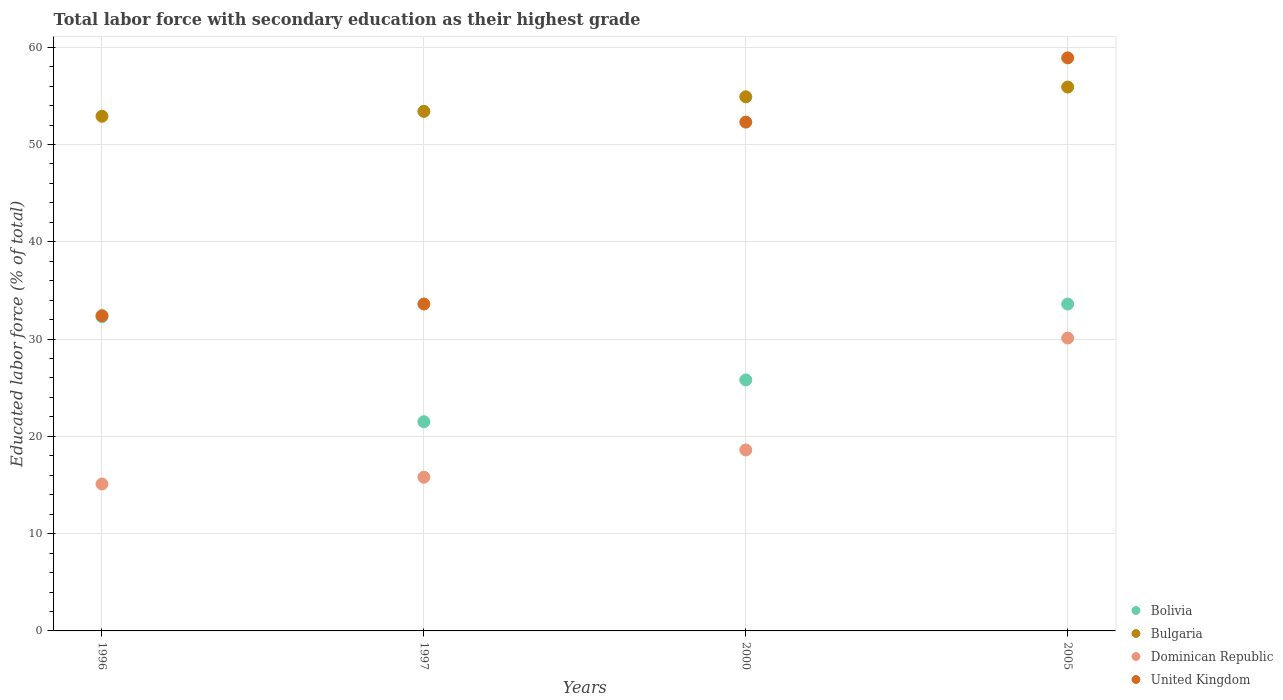How many different coloured dotlines are there?
Make the answer very short. 4. Is the number of dotlines equal to the number of legend labels?
Give a very brief answer. Yes. What is the percentage of total labor force with primary education in Bolivia in 1996?
Your answer should be compact. 32.3. Across all years, what is the maximum percentage of total labor force with primary education in United Kingdom?
Offer a very short reply. 58.9. Across all years, what is the minimum percentage of total labor force with primary education in Bulgaria?
Offer a very short reply. 52.9. In which year was the percentage of total labor force with primary education in Dominican Republic minimum?
Keep it short and to the point. 1996. What is the total percentage of total labor force with primary education in Bulgaria in the graph?
Your response must be concise. 217.1. What is the difference between the percentage of total labor force with primary education in Dominican Republic in 1997 and that in 2005?
Give a very brief answer. -14.3. What is the average percentage of total labor force with primary education in Bolivia per year?
Your response must be concise. 28.3. In the year 2000, what is the difference between the percentage of total labor force with primary education in Bolivia and percentage of total labor force with primary education in United Kingdom?
Make the answer very short. -26.5. What is the ratio of the percentage of total labor force with primary education in Bulgaria in 2000 to that in 2005?
Give a very brief answer. 0.98. Is the percentage of total labor force with primary education in United Kingdom in 1996 less than that in 2005?
Offer a terse response. Yes. What is the difference between the highest and the second highest percentage of total labor force with primary education in Dominican Republic?
Offer a terse response. 11.5. What is the difference between the highest and the lowest percentage of total labor force with primary education in United Kingdom?
Offer a very short reply. 26.5. In how many years, is the percentage of total labor force with primary education in Dominican Republic greater than the average percentage of total labor force with primary education in Dominican Republic taken over all years?
Your response must be concise. 1. Is the sum of the percentage of total labor force with primary education in Bolivia in 1996 and 2005 greater than the maximum percentage of total labor force with primary education in Dominican Republic across all years?
Make the answer very short. Yes. Is it the case that in every year, the sum of the percentage of total labor force with primary education in Bulgaria and percentage of total labor force with primary education in Dominican Republic  is greater than the sum of percentage of total labor force with primary education in United Kingdom and percentage of total labor force with primary education in Bolivia?
Give a very brief answer. No. Is it the case that in every year, the sum of the percentage of total labor force with primary education in Bolivia and percentage of total labor force with primary education in Dominican Republic  is greater than the percentage of total labor force with primary education in United Kingdom?
Provide a succinct answer. No. How many dotlines are there?
Offer a very short reply. 4. What is the difference between two consecutive major ticks on the Y-axis?
Provide a short and direct response. 10. Are the values on the major ticks of Y-axis written in scientific E-notation?
Ensure brevity in your answer.  No. Does the graph contain any zero values?
Give a very brief answer. No. Where does the legend appear in the graph?
Give a very brief answer. Bottom right. How many legend labels are there?
Provide a succinct answer. 4. What is the title of the graph?
Ensure brevity in your answer.  Total labor force with secondary education as their highest grade. Does "Germany" appear as one of the legend labels in the graph?
Keep it short and to the point. No. What is the label or title of the X-axis?
Provide a succinct answer. Years. What is the label or title of the Y-axis?
Offer a terse response. Educated labor force (% of total). What is the Educated labor force (% of total) of Bolivia in 1996?
Your answer should be very brief. 32.3. What is the Educated labor force (% of total) in Bulgaria in 1996?
Ensure brevity in your answer.  52.9. What is the Educated labor force (% of total) of Dominican Republic in 1996?
Keep it short and to the point. 15.1. What is the Educated labor force (% of total) in United Kingdom in 1996?
Your answer should be compact. 32.4. What is the Educated labor force (% of total) of Bolivia in 1997?
Ensure brevity in your answer.  21.5. What is the Educated labor force (% of total) of Bulgaria in 1997?
Provide a succinct answer. 53.4. What is the Educated labor force (% of total) in Dominican Republic in 1997?
Provide a short and direct response. 15.8. What is the Educated labor force (% of total) in United Kingdom in 1997?
Make the answer very short. 33.6. What is the Educated labor force (% of total) of Bolivia in 2000?
Your answer should be very brief. 25.8. What is the Educated labor force (% of total) in Bulgaria in 2000?
Your answer should be very brief. 54.9. What is the Educated labor force (% of total) of Dominican Republic in 2000?
Provide a short and direct response. 18.6. What is the Educated labor force (% of total) in United Kingdom in 2000?
Offer a very short reply. 52.3. What is the Educated labor force (% of total) of Bolivia in 2005?
Offer a terse response. 33.6. What is the Educated labor force (% of total) of Bulgaria in 2005?
Your answer should be very brief. 55.9. What is the Educated labor force (% of total) in Dominican Republic in 2005?
Keep it short and to the point. 30.1. What is the Educated labor force (% of total) in United Kingdom in 2005?
Ensure brevity in your answer.  58.9. Across all years, what is the maximum Educated labor force (% of total) in Bolivia?
Offer a terse response. 33.6. Across all years, what is the maximum Educated labor force (% of total) in Bulgaria?
Your answer should be very brief. 55.9. Across all years, what is the maximum Educated labor force (% of total) of Dominican Republic?
Offer a very short reply. 30.1. Across all years, what is the maximum Educated labor force (% of total) of United Kingdom?
Keep it short and to the point. 58.9. Across all years, what is the minimum Educated labor force (% of total) in Bolivia?
Give a very brief answer. 21.5. Across all years, what is the minimum Educated labor force (% of total) of Bulgaria?
Your answer should be compact. 52.9. Across all years, what is the minimum Educated labor force (% of total) in Dominican Republic?
Ensure brevity in your answer.  15.1. Across all years, what is the minimum Educated labor force (% of total) in United Kingdom?
Your answer should be compact. 32.4. What is the total Educated labor force (% of total) of Bolivia in the graph?
Make the answer very short. 113.2. What is the total Educated labor force (% of total) of Bulgaria in the graph?
Offer a very short reply. 217.1. What is the total Educated labor force (% of total) of Dominican Republic in the graph?
Ensure brevity in your answer.  79.6. What is the total Educated labor force (% of total) in United Kingdom in the graph?
Your answer should be compact. 177.2. What is the difference between the Educated labor force (% of total) in Bolivia in 1996 and that in 1997?
Offer a terse response. 10.8. What is the difference between the Educated labor force (% of total) of Bulgaria in 1996 and that in 1997?
Your answer should be very brief. -0.5. What is the difference between the Educated labor force (% of total) in Dominican Republic in 1996 and that in 1997?
Ensure brevity in your answer.  -0.7. What is the difference between the Educated labor force (% of total) in Bolivia in 1996 and that in 2000?
Your answer should be compact. 6.5. What is the difference between the Educated labor force (% of total) in Bulgaria in 1996 and that in 2000?
Your response must be concise. -2. What is the difference between the Educated labor force (% of total) in United Kingdom in 1996 and that in 2000?
Your answer should be compact. -19.9. What is the difference between the Educated labor force (% of total) of Bulgaria in 1996 and that in 2005?
Give a very brief answer. -3. What is the difference between the Educated labor force (% of total) in United Kingdom in 1996 and that in 2005?
Give a very brief answer. -26.5. What is the difference between the Educated labor force (% of total) of Bolivia in 1997 and that in 2000?
Keep it short and to the point. -4.3. What is the difference between the Educated labor force (% of total) in Bulgaria in 1997 and that in 2000?
Keep it short and to the point. -1.5. What is the difference between the Educated labor force (% of total) of Dominican Republic in 1997 and that in 2000?
Ensure brevity in your answer.  -2.8. What is the difference between the Educated labor force (% of total) of United Kingdom in 1997 and that in 2000?
Make the answer very short. -18.7. What is the difference between the Educated labor force (% of total) of Dominican Republic in 1997 and that in 2005?
Ensure brevity in your answer.  -14.3. What is the difference between the Educated labor force (% of total) in United Kingdom in 1997 and that in 2005?
Your answer should be very brief. -25.3. What is the difference between the Educated labor force (% of total) of Dominican Republic in 2000 and that in 2005?
Keep it short and to the point. -11.5. What is the difference between the Educated labor force (% of total) in United Kingdom in 2000 and that in 2005?
Make the answer very short. -6.6. What is the difference between the Educated labor force (% of total) in Bolivia in 1996 and the Educated labor force (% of total) in Bulgaria in 1997?
Ensure brevity in your answer.  -21.1. What is the difference between the Educated labor force (% of total) in Bolivia in 1996 and the Educated labor force (% of total) in Dominican Republic in 1997?
Offer a terse response. 16.5. What is the difference between the Educated labor force (% of total) of Bolivia in 1996 and the Educated labor force (% of total) of United Kingdom in 1997?
Give a very brief answer. -1.3. What is the difference between the Educated labor force (% of total) in Bulgaria in 1996 and the Educated labor force (% of total) in Dominican Republic in 1997?
Your answer should be compact. 37.1. What is the difference between the Educated labor force (% of total) in Bulgaria in 1996 and the Educated labor force (% of total) in United Kingdom in 1997?
Offer a terse response. 19.3. What is the difference between the Educated labor force (% of total) of Dominican Republic in 1996 and the Educated labor force (% of total) of United Kingdom in 1997?
Offer a very short reply. -18.5. What is the difference between the Educated labor force (% of total) in Bolivia in 1996 and the Educated labor force (% of total) in Bulgaria in 2000?
Provide a short and direct response. -22.6. What is the difference between the Educated labor force (% of total) of Bolivia in 1996 and the Educated labor force (% of total) of United Kingdom in 2000?
Your answer should be compact. -20. What is the difference between the Educated labor force (% of total) of Bulgaria in 1996 and the Educated labor force (% of total) of Dominican Republic in 2000?
Provide a succinct answer. 34.3. What is the difference between the Educated labor force (% of total) in Bulgaria in 1996 and the Educated labor force (% of total) in United Kingdom in 2000?
Ensure brevity in your answer.  0.6. What is the difference between the Educated labor force (% of total) of Dominican Republic in 1996 and the Educated labor force (% of total) of United Kingdom in 2000?
Give a very brief answer. -37.2. What is the difference between the Educated labor force (% of total) of Bolivia in 1996 and the Educated labor force (% of total) of Bulgaria in 2005?
Give a very brief answer. -23.6. What is the difference between the Educated labor force (% of total) of Bolivia in 1996 and the Educated labor force (% of total) of United Kingdom in 2005?
Your response must be concise. -26.6. What is the difference between the Educated labor force (% of total) of Bulgaria in 1996 and the Educated labor force (% of total) of Dominican Republic in 2005?
Provide a succinct answer. 22.8. What is the difference between the Educated labor force (% of total) in Bulgaria in 1996 and the Educated labor force (% of total) in United Kingdom in 2005?
Your answer should be very brief. -6. What is the difference between the Educated labor force (% of total) in Dominican Republic in 1996 and the Educated labor force (% of total) in United Kingdom in 2005?
Provide a short and direct response. -43.8. What is the difference between the Educated labor force (% of total) in Bolivia in 1997 and the Educated labor force (% of total) in Bulgaria in 2000?
Your response must be concise. -33.4. What is the difference between the Educated labor force (% of total) of Bolivia in 1997 and the Educated labor force (% of total) of Dominican Republic in 2000?
Offer a very short reply. 2.9. What is the difference between the Educated labor force (% of total) in Bolivia in 1997 and the Educated labor force (% of total) in United Kingdom in 2000?
Offer a terse response. -30.8. What is the difference between the Educated labor force (% of total) in Bulgaria in 1997 and the Educated labor force (% of total) in Dominican Republic in 2000?
Your response must be concise. 34.8. What is the difference between the Educated labor force (% of total) in Bulgaria in 1997 and the Educated labor force (% of total) in United Kingdom in 2000?
Offer a terse response. 1.1. What is the difference between the Educated labor force (% of total) in Dominican Republic in 1997 and the Educated labor force (% of total) in United Kingdom in 2000?
Make the answer very short. -36.5. What is the difference between the Educated labor force (% of total) of Bolivia in 1997 and the Educated labor force (% of total) of Bulgaria in 2005?
Ensure brevity in your answer.  -34.4. What is the difference between the Educated labor force (% of total) in Bolivia in 1997 and the Educated labor force (% of total) in United Kingdom in 2005?
Provide a short and direct response. -37.4. What is the difference between the Educated labor force (% of total) of Bulgaria in 1997 and the Educated labor force (% of total) of Dominican Republic in 2005?
Your answer should be compact. 23.3. What is the difference between the Educated labor force (% of total) of Bulgaria in 1997 and the Educated labor force (% of total) of United Kingdom in 2005?
Keep it short and to the point. -5.5. What is the difference between the Educated labor force (% of total) of Dominican Republic in 1997 and the Educated labor force (% of total) of United Kingdom in 2005?
Offer a terse response. -43.1. What is the difference between the Educated labor force (% of total) of Bolivia in 2000 and the Educated labor force (% of total) of Bulgaria in 2005?
Your response must be concise. -30.1. What is the difference between the Educated labor force (% of total) in Bolivia in 2000 and the Educated labor force (% of total) in Dominican Republic in 2005?
Keep it short and to the point. -4.3. What is the difference between the Educated labor force (% of total) in Bolivia in 2000 and the Educated labor force (% of total) in United Kingdom in 2005?
Offer a terse response. -33.1. What is the difference between the Educated labor force (% of total) of Bulgaria in 2000 and the Educated labor force (% of total) of Dominican Republic in 2005?
Provide a short and direct response. 24.8. What is the difference between the Educated labor force (% of total) in Dominican Republic in 2000 and the Educated labor force (% of total) in United Kingdom in 2005?
Your response must be concise. -40.3. What is the average Educated labor force (% of total) in Bolivia per year?
Keep it short and to the point. 28.3. What is the average Educated labor force (% of total) of Bulgaria per year?
Make the answer very short. 54.27. What is the average Educated labor force (% of total) in United Kingdom per year?
Offer a terse response. 44.3. In the year 1996, what is the difference between the Educated labor force (% of total) of Bolivia and Educated labor force (% of total) of Bulgaria?
Your response must be concise. -20.6. In the year 1996, what is the difference between the Educated labor force (% of total) of Bolivia and Educated labor force (% of total) of United Kingdom?
Your answer should be very brief. -0.1. In the year 1996, what is the difference between the Educated labor force (% of total) in Bulgaria and Educated labor force (% of total) in Dominican Republic?
Ensure brevity in your answer.  37.8. In the year 1996, what is the difference between the Educated labor force (% of total) in Dominican Republic and Educated labor force (% of total) in United Kingdom?
Offer a terse response. -17.3. In the year 1997, what is the difference between the Educated labor force (% of total) of Bolivia and Educated labor force (% of total) of Bulgaria?
Your answer should be compact. -31.9. In the year 1997, what is the difference between the Educated labor force (% of total) in Bolivia and Educated labor force (% of total) in Dominican Republic?
Provide a short and direct response. 5.7. In the year 1997, what is the difference between the Educated labor force (% of total) of Bolivia and Educated labor force (% of total) of United Kingdom?
Offer a terse response. -12.1. In the year 1997, what is the difference between the Educated labor force (% of total) in Bulgaria and Educated labor force (% of total) in Dominican Republic?
Ensure brevity in your answer.  37.6. In the year 1997, what is the difference between the Educated labor force (% of total) in Bulgaria and Educated labor force (% of total) in United Kingdom?
Keep it short and to the point. 19.8. In the year 1997, what is the difference between the Educated labor force (% of total) of Dominican Republic and Educated labor force (% of total) of United Kingdom?
Provide a short and direct response. -17.8. In the year 2000, what is the difference between the Educated labor force (% of total) of Bolivia and Educated labor force (% of total) of Bulgaria?
Your response must be concise. -29.1. In the year 2000, what is the difference between the Educated labor force (% of total) of Bolivia and Educated labor force (% of total) of Dominican Republic?
Provide a succinct answer. 7.2. In the year 2000, what is the difference between the Educated labor force (% of total) in Bolivia and Educated labor force (% of total) in United Kingdom?
Your response must be concise. -26.5. In the year 2000, what is the difference between the Educated labor force (% of total) in Bulgaria and Educated labor force (% of total) in Dominican Republic?
Give a very brief answer. 36.3. In the year 2000, what is the difference between the Educated labor force (% of total) of Bulgaria and Educated labor force (% of total) of United Kingdom?
Your answer should be very brief. 2.6. In the year 2000, what is the difference between the Educated labor force (% of total) of Dominican Republic and Educated labor force (% of total) of United Kingdom?
Your answer should be very brief. -33.7. In the year 2005, what is the difference between the Educated labor force (% of total) of Bolivia and Educated labor force (% of total) of Bulgaria?
Offer a terse response. -22.3. In the year 2005, what is the difference between the Educated labor force (% of total) in Bolivia and Educated labor force (% of total) in United Kingdom?
Keep it short and to the point. -25.3. In the year 2005, what is the difference between the Educated labor force (% of total) in Bulgaria and Educated labor force (% of total) in Dominican Republic?
Provide a succinct answer. 25.8. In the year 2005, what is the difference between the Educated labor force (% of total) in Bulgaria and Educated labor force (% of total) in United Kingdom?
Provide a succinct answer. -3. In the year 2005, what is the difference between the Educated labor force (% of total) of Dominican Republic and Educated labor force (% of total) of United Kingdom?
Offer a terse response. -28.8. What is the ratio of the Educated labor force (% of total) of Bolivia in 1996 to that in 1997?
Keep it short and to the point. 1.5. What is the ratio of the Educated labor force (% of total) of Bulgaria in 1996 to that in 1997?
Offer a very short reply. 0.99. What is the ratio of the Educated labor force (% of total) of Dominican Republic in 1996 to that in 1997?
Your answer should be compact. 0.96. What is the ratio of the Educated labor force (% of total) of Bolivia in 1996 to that in 2000?
Offer a terse response. 1.25. What is the ratio of the Educated labor force (% of total) in Bulgaria in 1996 to that in 2000?
Provide a succinct answer. 0.96. What is the ratio of the Educated labor force (% of total) in Dominican Republic in 1996 to that in 2000?
Ensure brevity in your answer.  0.81. What is the ratio of the Educated labor force (% of total) of United Kingdom in 1996 to that in 2000?
Your response must be concise. 0.62. What is the ratio of the Educated labor force (% of total) of Bolivia in 1996 to that in 2005?
Your response must be concise. 0.96. What is the ratio of the Educated labor force (% of total) of Bulgaria in 1996 to that in 2005?
Offer a very short reply. 0.95. What is the ratio of the Educated labor force (% of total) in Dominican Republic in 1996 to that in 2005?
Your response must be concise. 0.5. What is the ratio of the Educated labor force (% of total) of United Kingdom in 1996 to that in 2005?
Keep it short and to the point. 0.55. What is the ratio of the Educated labor force (% of total) of Bolivia in 1997 to that in 2000?
Your answer should be compact. 0.83. What is the ratio of the Educated labor force (% of total) in Bulgaria in 1997 to that in 2000?
Keep it short and to the point. 0.97. What is the ratio of the Educated labor force (% of total) in Dominican Republic in 1997 to that in 2000?
Give a very brief answer. 0.85. What is the ratio of the Educated labor force (% of total) in United Kingdom in 1997 to that in 2000?
Offer a very short reply. 0.64. What is the ratio of the Educated labor force (% of total) of Bolivia in 1997 to that in 2005?
Provide a succinct answer. 0.64. What is the ratio of the Educated labor force (% of total) in Bulgaria in 1997 to that in 2005?
Offer a very short reply. 0.96. What is the ratio of the Educated labor force (% of total) in Dominican Republic in 1997 to that in 2005?
Provide a short and direct response. 0.52. What is the ratio of the Educated labor force (% of total) in United Kingdom in 1997 to that in 2005?
Provide a short and direct response. 0.57. What is the ratio of the Educated labor force (% of total) in Bolivia in 2000 to that in 2005?
Your answer should be very brief. 0.77. What is the ratio of the Educated labor force (% of total) in Bulgaria in 2000 to that in 2005?
Your response must be concise. 0.98. What is the ratio of the Educated labor force (% of total) of Dominican Republic in 2000 to that in 2005?
Offer a terse response. 0.62. What is the ratio of the Educated labor force (% of total) of United Kingdom in 2000 to that in 2005?
Offer a terse response. 0.89. What is the difference between the highest and the second highest Educated labor force (% of total) in Bulgaria?
Your answer should be very brief. 1. What is the difference between the highest and the second highest Educated labor force (% of total) of Dominican Republic?
Ensure brevity in your answer.  11.5. What is the difference between the highest and the second highest Educated labor force (% of total) of United Kingdom?
Keep it short and to the point. 6.6. What is the difference between the highest and the lowest Educated labor force (% of total) of Bolivia?
Provide a succinct answer. 12.1. What is the difference between the highest and the lowest Educated labor force (% of total) of Bulgaria?
Your response must be concise. 3. 